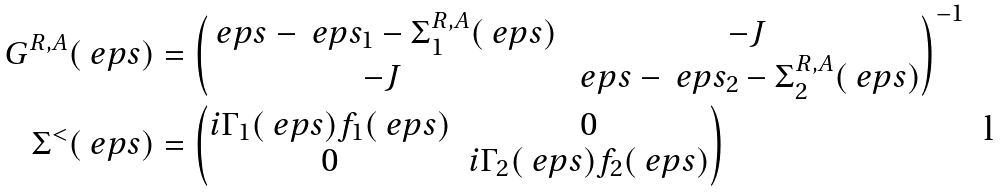Convert formula to latex. <formula><loc_0><loc_0><loc_500><loc_500>G ^ { R , A } ( \ e p s ) & = \begin{pmatrix} \ e p s - \ e p s _ { 1 } - \Sigma ^ { R , A } _ { 1 } ( \ e p s ) & - J \\ - J & \ e p s - \ e p s _ { 2 } - \Sigma ^ { R , A } _ { 2 } ( \ e p s ) \end{pmatrix} ^ { - 1 } \\ \Sigma ^ { < } ( \ e p s ) & = \begin{pmatrix} i \Gamma _ { 1 } ( \ e p s ) f _ { 1 } ( \ e p s ) & 0 \\ 0 & i \Gamma _ { 2 } ( \ e p s ) f _ { 2 } ( \ e p s ) \end{pmatrix}</formula> 